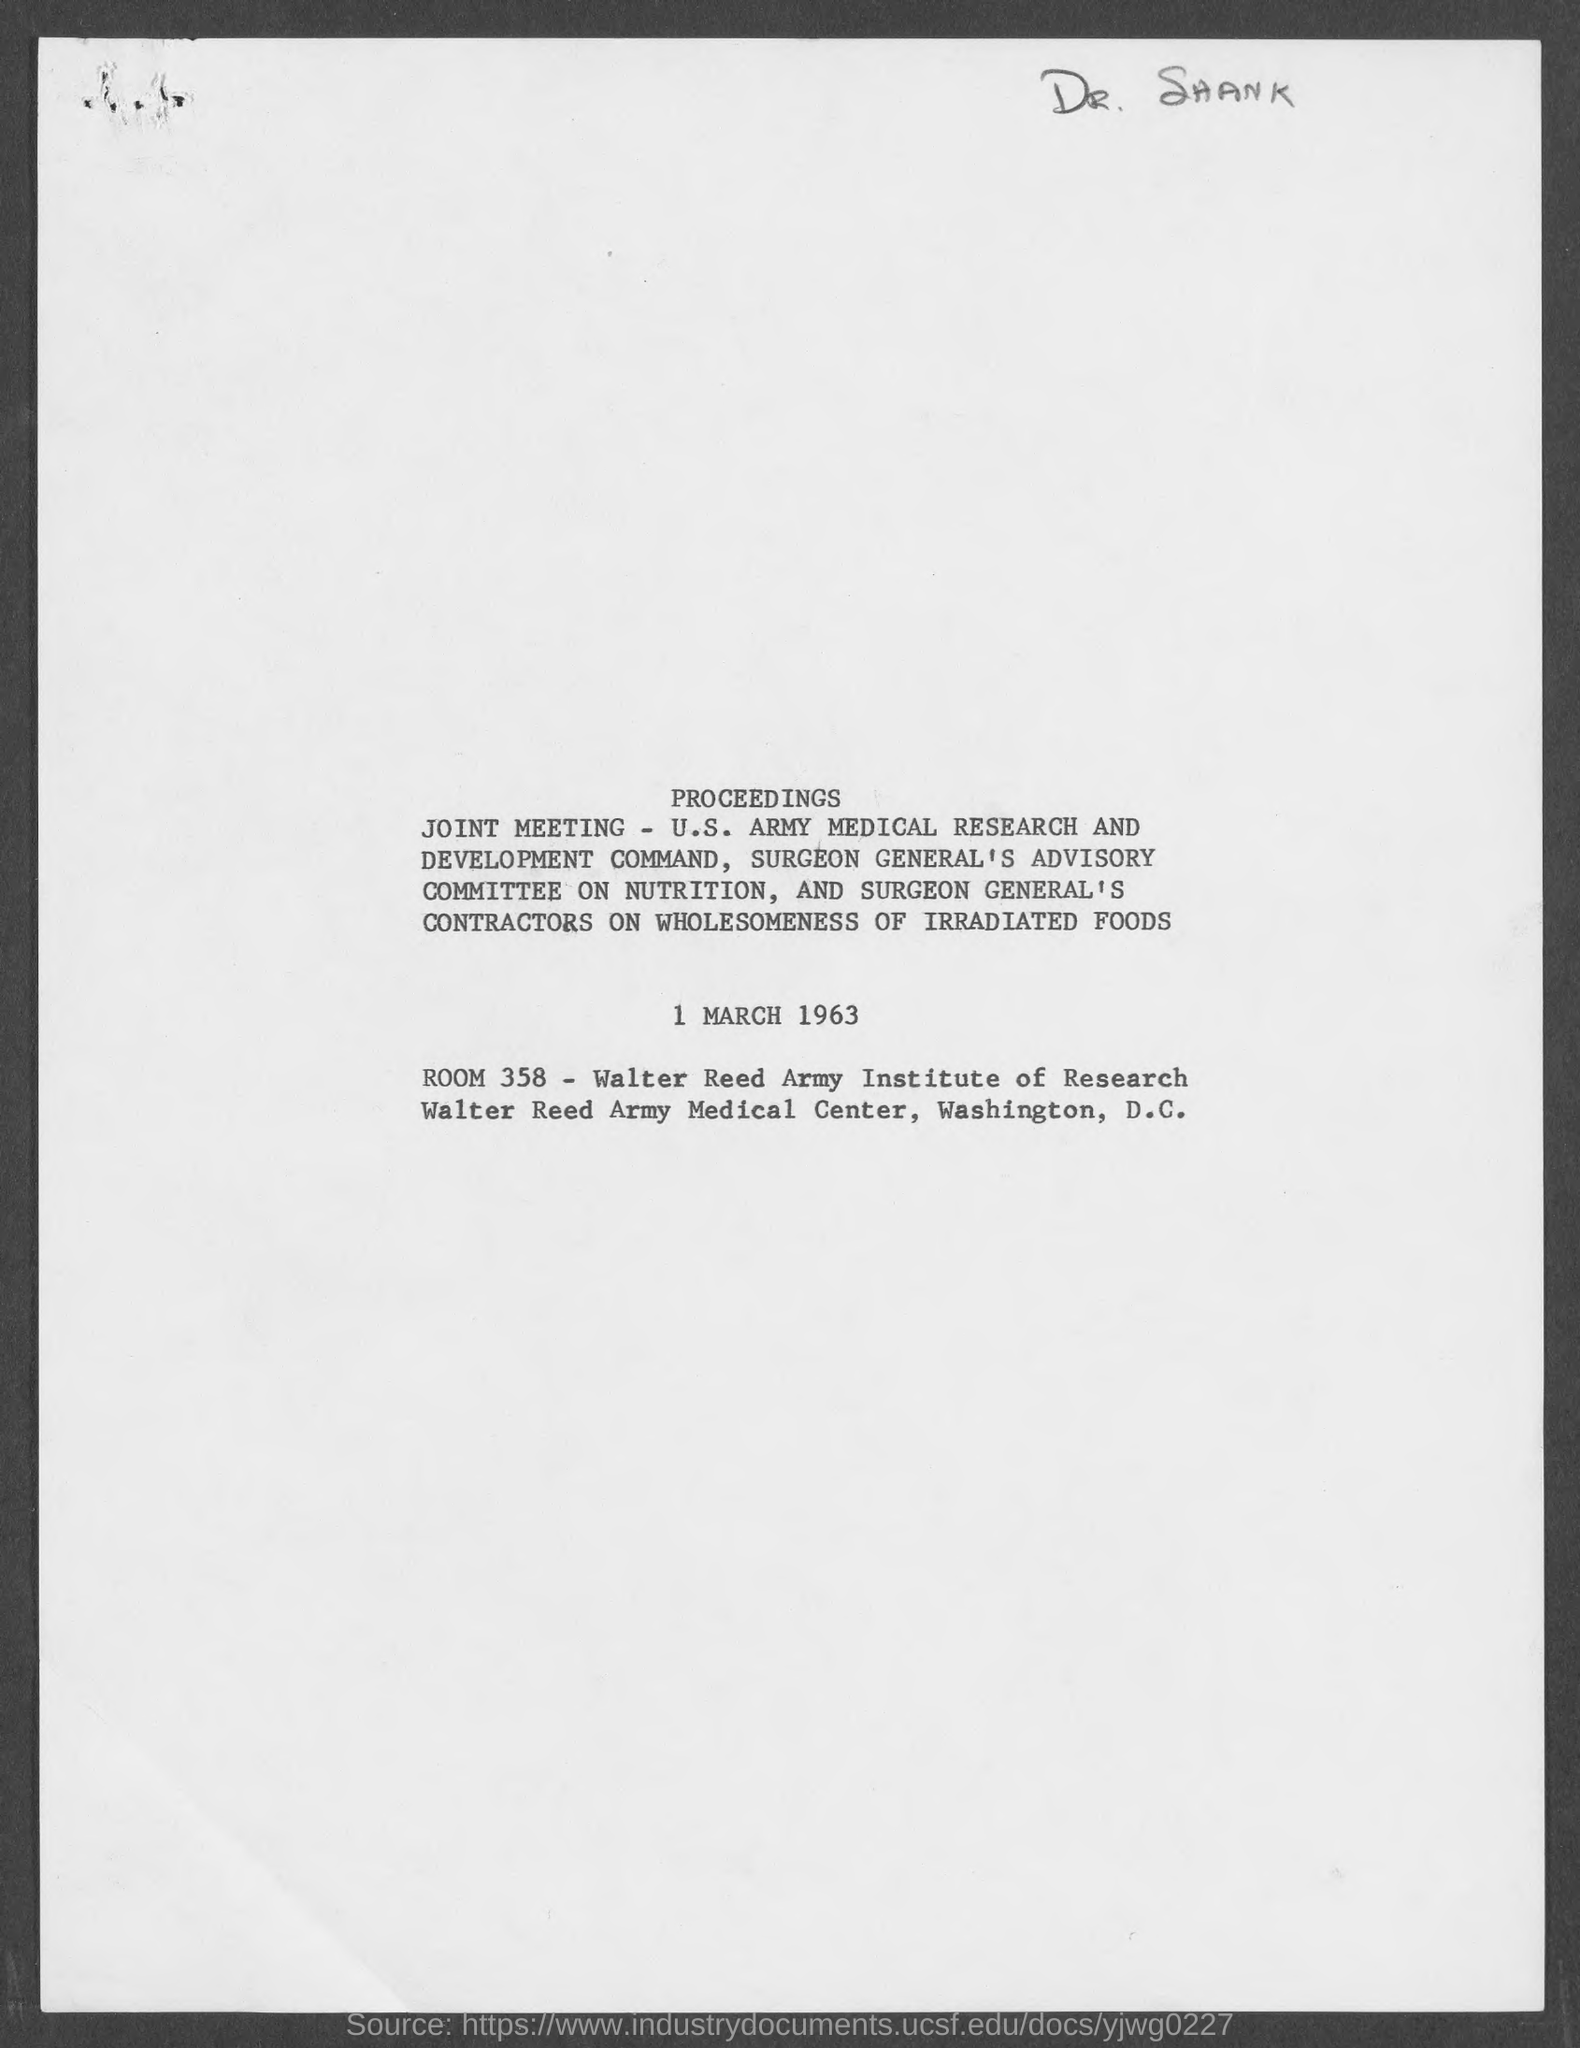Outline some significant characteristics in this image. The ROOM is a telecommunications device that consists of 358 digits. The date is March 1, 1963. 